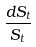Convert formula to latex. <formula><loc_0><loc_0><loc_500><loc_500>\frac { d S _ { t } } { S _ { t } }</formula> 